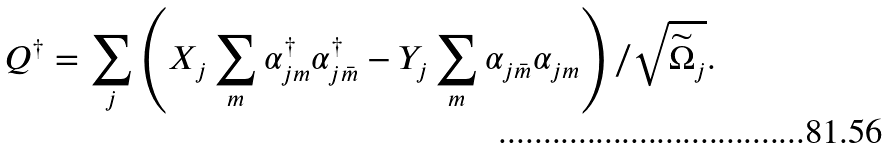Convert formula to latex. <formula><loc_0><loc_0><loc_500><loc_500>Q ^ { \dagger } = \sum _ { j } \left ( X _ { j } \sum _ { m } \alpha _ { j m } ^ { \dagger } \alpha _ { j \bar { m } } ^ { \dagger } - Y _ { j } \sum _ { m } \alpha _ { j \bar { m } } \alpha _ { j m } \right ) / \sqrt { \widetilde { \Omega } _ { j } } .</formula> 